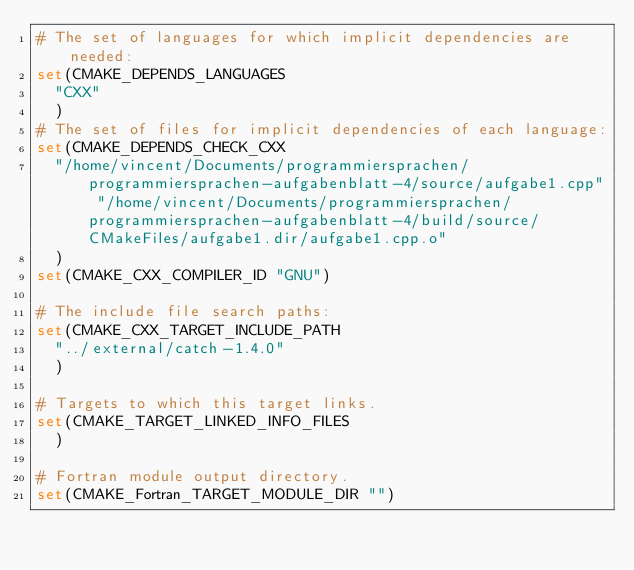Convert code to text. <code><loc_0><loc_0><loc_500><loc_500><_CMake_># The set of languages for which implicit dependencies are needed:
set(CMAKE_DEPENDS_LANGUAGES
  "CXX"
  )
# The set of files for implicit dependencies of each language:
set(CMAKE_DEPENDS_CHECK_CXX
  "/home/vincent/Documents/programmiersprachen/programmiersprachen-aufgabenblatt-4/source/aufgabe1.cpp" "/home/vincent/Documents/programmiersprachen/programmiersprachen-aufgabenblatt-4/build/source/CMakeFiles/aufgabe1.dir/aufgabe1.cpp.o"
  )
set(CMAKE_CXX_COMPILER_ID "GNU")

# The include file search paths:
set(CMAKE_CXX_TARGET_INCLUDE_PATH
  "../external/catch-1.4.0"
  )

# Targets to which this target links.
set(CMAKE_TARGET_LINKED_INFO_FILES
  )

# Fortran module output directory.
set(CMAKE_Fortran_TARGET_MODULE_DIR "")
</code> 